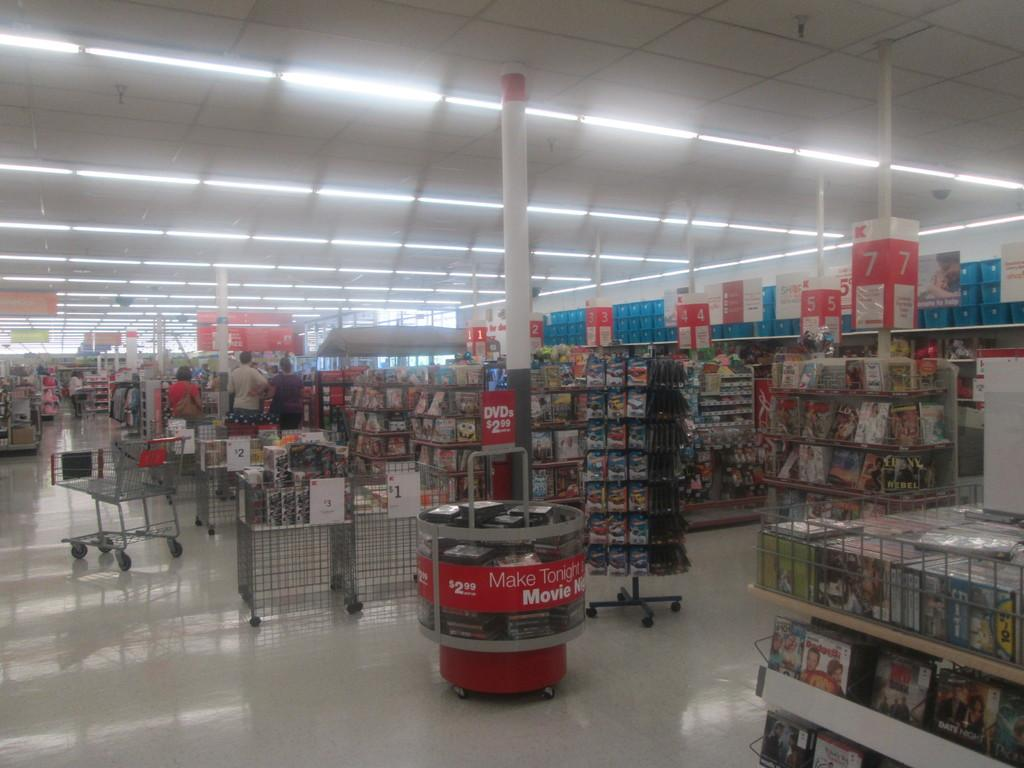<image>
Offer a succinct explanation of the picture presented. A cart of DVDs in store with a sign that says "make tonight a movie night" 